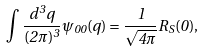<formula> <loc_0><loc_0><loc_500><loc_500>\int \frac { d ^ { 3 } q } { ( 2 \pi ) ^ { 3 } } \psi _ { 0 0 } ( { q } ) = \frac { 1 } { \sqrt { 4 \pi } } R _ { S } ( 0 ) ,</formula> 